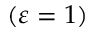Convert formula to latex. <formula><loc_0><loc_0><loc_500><loc_500>( \varepsilon = 1 )</formula> 